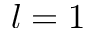<formula> <loc_0><loc_0><loc_500><loc_500>l = 1</formula> 